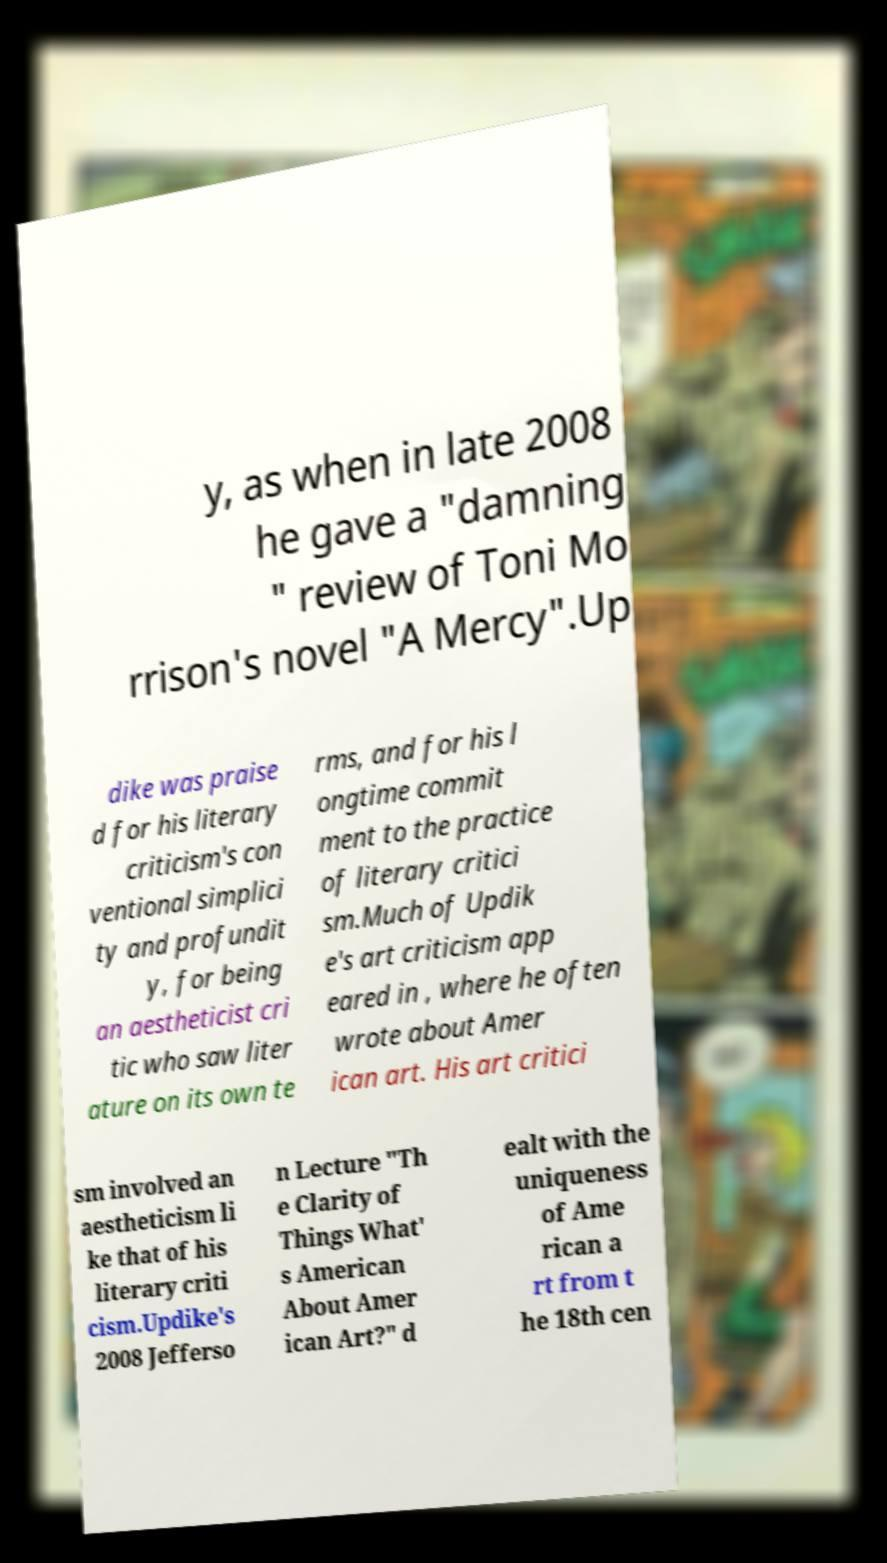I need the written content from this picture converted into text. Can you do that? y, as when in late 2008 he gave a "damning " review of Toni Mo rrison's novel "A Mercy".Up dike was praise d for his literary criticism's con ventional simplici ty and profundit y, for being an aestheticist cri tic who saw liter ature on its own te rms, and for his l ongtime commit ment to the practice of literary critici sm.Much of Updik e's art criticism app eared in , where he often wrote about Amer ican art. His art critici sm involved an aestheticism li ke that of his literary criti cism.Updike's 2008 Jefferso n Lecture "Th e Clarity of Things What' s American About Amer ican Art?" d ealt with the uniqueness of Ame rican a rt from t he 18th cen 